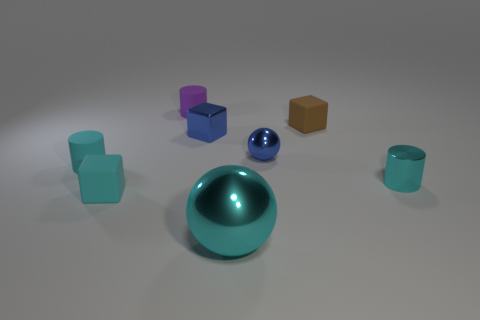Is the number of big red rubber things less than the number of small blue cubes?
Offer a very short reply. Yes. How many small cyan rubber cubes are to the right of the purple matte cylinder?
Offer a very short reply. 0. What is the large cyan thing made of?
Make the answer very short. Metal. Do the large metal object and the small metallic cylinder have the same color?
Ensure brevity in your answer.  Yes. Are there fewer metal spheres that are on the left side of the blue ball than gray things?
Your response must be concise. No. The small block that is on the right side of the big metallic thing is what color?
Your answer should be compact. Brown. What is the shape of the small brown thing?
Make the answer very short. Cube. There is a ball in front of the tiny rubber cube that is to the left of the purple cylinder; is there a large metal object left of it?
Make the answer very short. No. What is the color of the matte block on the right side of the rubber object behind the brown block that is on the right side of the purple matte thing?
Offer a very short reply. Brown. What material is the tiny blue thing that is the same shape as the brown object?
Your answer should be compact. Metal. 